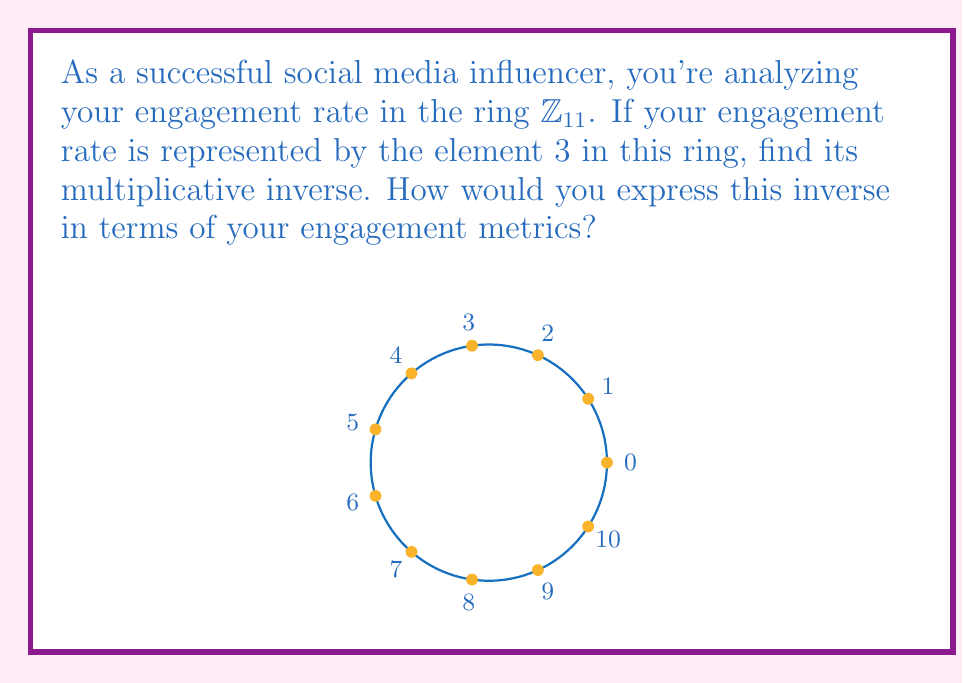Provide a solution to this math problem. To find the multiplicative inverse of 3 in $\mathbb{Z}_{11}$, we need to find an element $x$ such that:

$$3x \equiv 1 \pmod{11}$$

We can solve this using the following steps:

1) Multiply both sides by 3 (which is valid since 3 and 11 are coprime):
   $$9x \equiv 3 \pmod{11}$$

2) Add 11 to the right side (which doesn't change the congruence):
   $$9x \equiv 14 \pmod{11}$$

3) Simplify the right side:
   $$9x \equiv 3 \pmod{11}$$

4) Multiply both sides by 4 (the multiplicative inverse of 9 mod 11):
   $$x \equiv 12 \pmod{11}$$

5) Simplify:
   $$x \equiv 1 \pmod{11}$$

Therefore, the multiplicative inverse of 3 in $\mathbb{Z}_{11}$ is 4.

In terms of engagement metrics, this means that if your current engagement rate is represented by 3, you would need to increase it by a factor of 4 to achieve a "perfect" engagement rate of 1 in this ring.
Answer: $4$ 